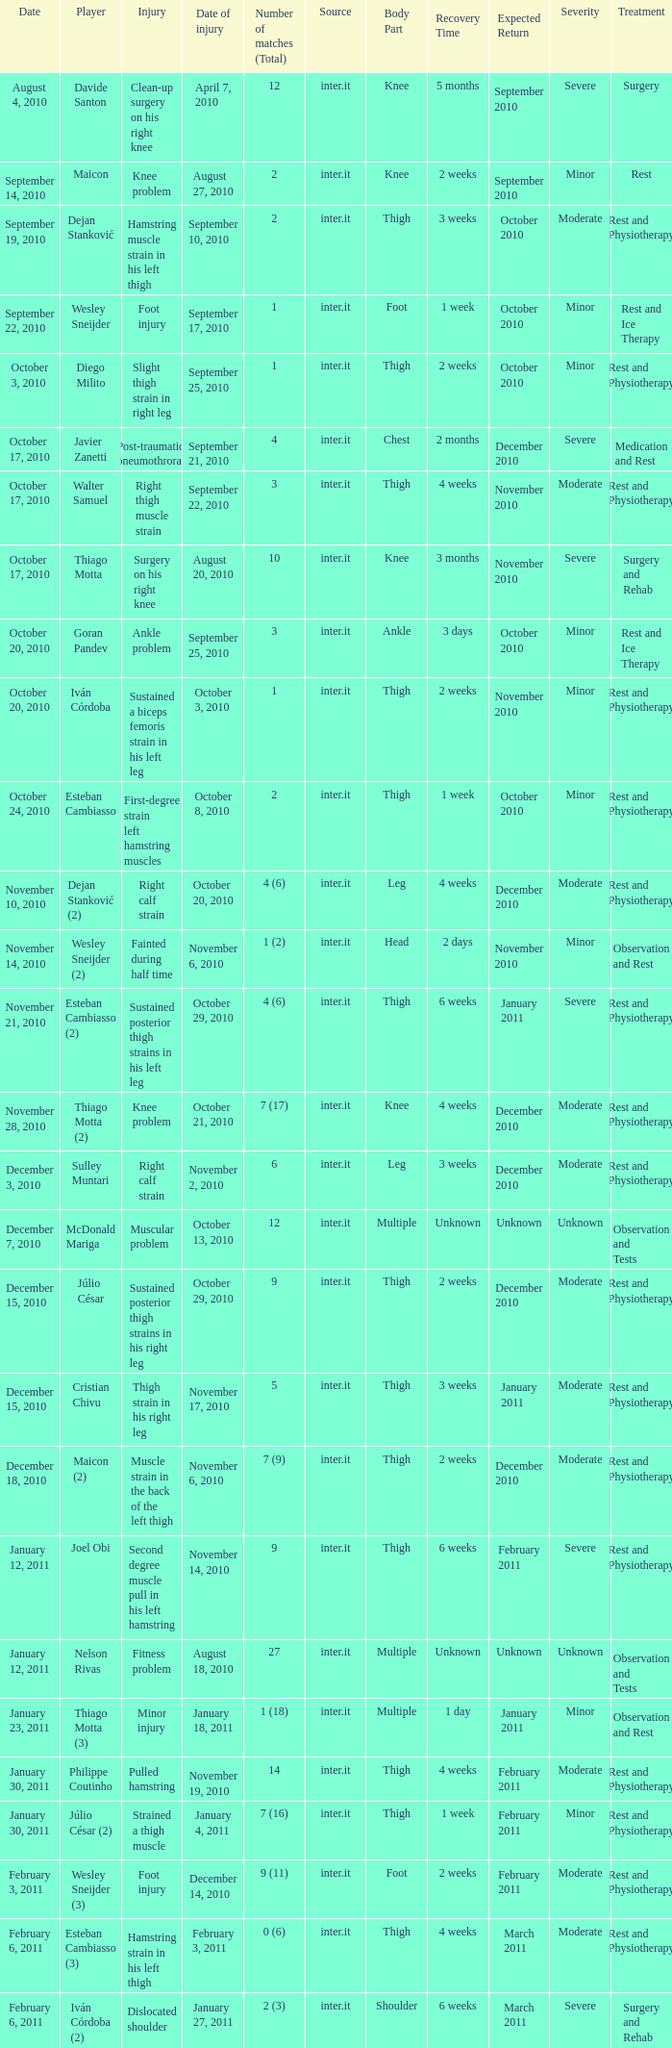Would you mind parsing the complete table? {'header': ['Date', 'Player', 'Injury', 'Date of injury', 'Number of matches (Total)', 'Source', 'Body Part', 'Recovery Time', 'Expected Return', 'Severity', 'Treatment'], 'rows': [['August 4, 2010', 'Davide Santon', 'Clean-up surgery on his right knee', 'April 7, 2010', '12', 'inter.it', 'Knee', '5 months', 'September 2010', 'Severe', 'Surgery'], ['September 14, 2010', 'Maicon', 'Knee problem', 'August 27, 2010', '2', 'inter.it', 'Knee', '2 weeks', 'September 2010', 'Minor', 'Rest'], ['September 19, 2010', 'Dejan Stanković', 'Hamstring muscle strain in his left thigh', 'September 10, 2010', '2', 'inter.it', 'Thigh', '3 weeks', 'October 2010', 'Moderate', 'Rest and Physiotherapy'], ['September 22, 2010', 'Wesley Sneijder', 'Foot injury', 'September 17, 2010', '1', 'inter.it', 'Foot', '1 week', 'October 2010', 'Minor', 'Rest and Ice Therapy'], ['October 3, 2010', 'Diego Milito', 'Slight thigh strain in right leg', 'September 25, 2010', '1', 'inter.it', 'Thigh', '2 weeks', 'October 2010', 'Minor', 'Rest and Physiotherapy'], ['October 17, 2010', 'Javier Zanetti', 'Post-traumatic pneumothrorax', 'September 21, 2010', '4', 'inter.it', 'Chest', '2 months', 'December 2010', 'Severe', 'Medication and Rest'], ['October 17, 2010', 'Walter Samuel', 'Right thigh muscle strain', 'September 22, 2010', '3', 'inter.it', 'Thigh', '4 weeks', 'November 2010', 'Moderate', 'Rest and Physiotherapy'], ['October 17, 2010', 'Thiago Motta', 'Surgery on his right knee', 'August 20, 2010', '10', 'inter.it', 'Knee', '3 months', 'November 2010', 'Severe', 'Surgery and Rehab'], ['October 20, 2010', 'Goran Pandev', 'Ankle problem', 'September 25, 2010', '3', 'inter.it', 'Ankle', '3 days', 'October 2010', 'Minor', 'Rest and Ice Therapy'], ['October 20, 2010', 'Iván Córdoba', 'Sustained a biceps femoris strain in his left leg', 'October 3, 2010', '1', 'inter.it', 'Thigh', '2 weeks', 'November 2010', 'Minor', 'Rest and Physiotherapy'], ['October 24, 2010', 'Esteban Cambiasso', 'First-degree strain left hamstring muscles', 'October 8, 2010', '2', 'inter.it', 'Thigh', '1 week', 'October 2010', 'Minor', 'Rest and Physiotherapy'], ['November 10, 2010', 'Dejan Stanković (2)', 'Right calf strain', 'October 20, 2010', '4 (6)', 'inter.it', 'Leg', '4 weeks', 'December 2010', 'Moderate', 'Rest and Physiotherapy'], ['November 14, 2010', 'Wesley Sneijder (2)', 'Fainted during half time', 'November 6, 2010', '1 (2)', 'inter.it', 'Head', '2 days', 'November 2010', 'Minor', 'Observation and Rest'], ['November 21, 2010', 'Esteban Cambiasso (2)', 'Sustained posterior thigh strains in his left leg', 'October 29, 2010', '4 (6)', 'inter.it', 'Thigh', '6 weeks', 'January 2011', 'Severe', 'Rest and Physiotherapy'], ['November 28, 2010', 'Thiago Motta (2)', 'Knee problem', 'October 21, 2010', '7 (17)', 'inter.it', 'Knee', '4 weeks', 'December 2010', 'Moderate', 'Rest and Physiotherapy'], ['December 3, 2010', 'Sulley Muntari', 'Right calf strain', 'November 2, 2010', '6', 'inter.it', 'Leg', '3 weeks', 'December 2010', 'Moderate', 'Rest and Physiotherapy'], ['December 7, 2010', 'McDonald Mariga', 'Muscular problem', 'October 13, 2010', '12', 'inter.it', 'Multiple', 'Unknown', 'Unknown', 'Unknown', 'Observation and Tests'], ['December 15, 2010', 'Júlio César', 'Sustained posterior thigh strains in his right leg', 'October 29, 2010', '9', 'inter.it', 'Thigh', '2 weeks', 'December 2010', 'Moderate', 'Rest and Physiotherapy'], ['December 15, 2010', 'Cristian Chivu', 'Thigh strain in his right leg', 'November 17, 2010', '5', 'inter.it', 'Thigh', '3 weeks', 'January 2011', 'Moderate', 'Rest and Physiotherapy'], ['December 18, 2010', 'Maicon (2)', 'Muscle strain in the back of the left thigh', 'November 6, 2010', '7 (9)', 'inter.it', 'Thigh', '2 weeks', 'December 2010', 'Moderate', 'Rest and Physiotherapy'], ['January 12, 2011', 'Joel Obi', 'Second degree muscle pull in his left hamstring', 'November 14, 2010', '9', 'inter.it', 'Thigh', '6 weeks', 'February 2011', 'Severe', 'Rest and Physiotherapy'], ['January 12, 2011', 'Nelson Rivas', 'Fitness problem', 'August 18, 2010', '27', 'inter.it', 'Multiple', 'Unknown', 'Unknown', 'Unknown', 'Observation and Tests'], ['January 23, 2011', 'Thiago Motta (3)', 'Minor injury', 'January 18, 2011', '1 (18)', 'inter.it', 'Multiple', '1 day', 'January 2011', 'Minor', 'Observation and Rest'], ['January 30, 2011', 'Philippe Coutinho', 'Pulled hamstring', 'November 19, 2010', '14', 'inter.it', 'Thigh', '4 weeks', 'February 2011', 'Moderate', 'Rest and Physiotherapy'], ['January 30, 2011', 'Júlio César (2)', 'Strained a thigh muscle', 'January 4, 2011', '7 (16)', 'inter.it', 'Thigh', '1 week', 'February 2011', 'Minor', 'Rest and Physiotherapy'], ['February 3, 2011', 'Wesley Sneijder (3)', 'Foot injury', 'December 14, 2010', '9 (11)', 'inter.it', 'Foot', '2 weeks', 'February 2011', 'Moderate', 'Rest and Physiotherapy'], ['February 6, 2011', 'Esteban Cambiasso (3)', 'Hamstring strain in his left thigh', 'February 3, 2011', '0 (6)', 'inter.it', 'Thigh', '4 weeks', 'March 2011', 'Moderate', 'Rest and Physiotherapy'], ['February 6, 2011', 'Iván Córdoba (2)', 'Dislocated shoulder', 'January 27, 2011', '2 (3)', 'inter.it', 'Shoulder', '6 weeks', 'March 2011', 'Severe', 'Surgery and Rehab'], ['February 6, 2011', 'Luca Castellazzi', 'Right hand injury', 'January 29, 2011', '2', 'inter.it', 'Hand', '1 week', 'February 2011', 'Minor', 'Rest and Ice Therapy'], ['February 16, 2011', 'Dejan Stanković (3)', 'Pulled a muscle in this right thigh', 'January 27, 2011', '4 (10)', 'inter.it', 'Thigh', '2 weeks', 'March 2011', 'Moderate', 'Rest and Physiotherapy'], ['February 23, 2011', 'Lúcio', 'Pulled an adductor muscle in his right thigh', 'January 31, 2011', '5', 'inter.it', 'Thigh', '3 weeks', 'March 2011', 'Moderate', 'Rest and Physiotherapy']]} What is the date of injury when the injury is foot injury and the number of matches (total) is 1? September 17, 2010. 